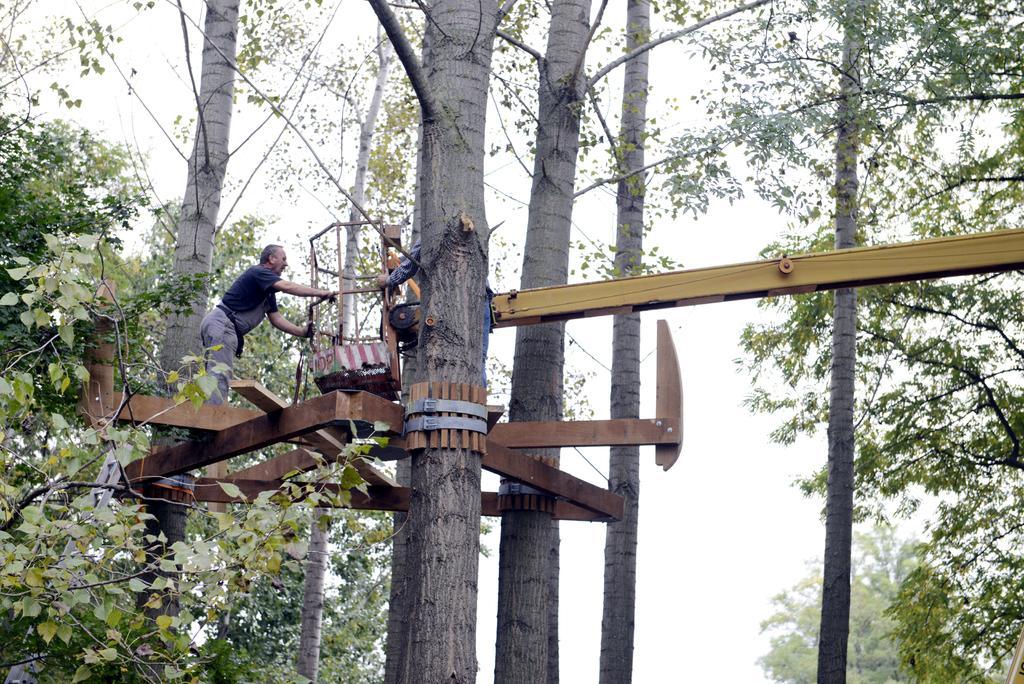Please provide a concise description of this image. In the image we can see there are people standing on the iron rods which are attached to the trees. 